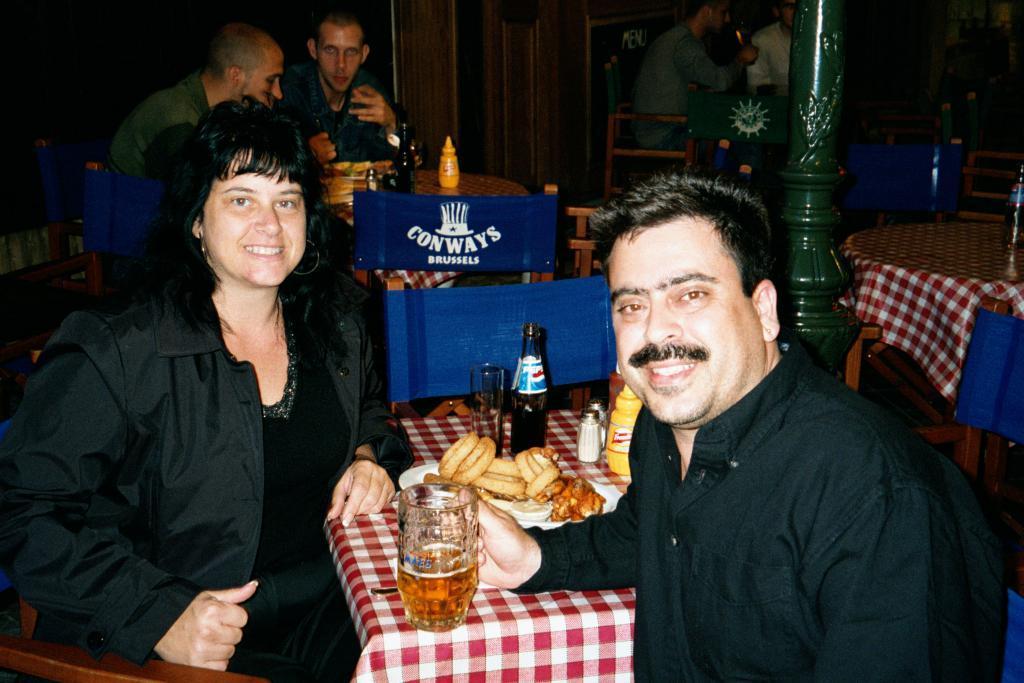Can you describe this image briefly? This is a picture consist of number of persons and there are so many tables visible and on the tables there are red cloth kept on that. On the middle a person wearing a black color shirt he is smiling and his holding a glass and on the table table there is a food and there is a bottle , glass , kept on that. And a woman wearing a black color skirt she is smiling , back side of the women there are two persons sitting in front of the table. 